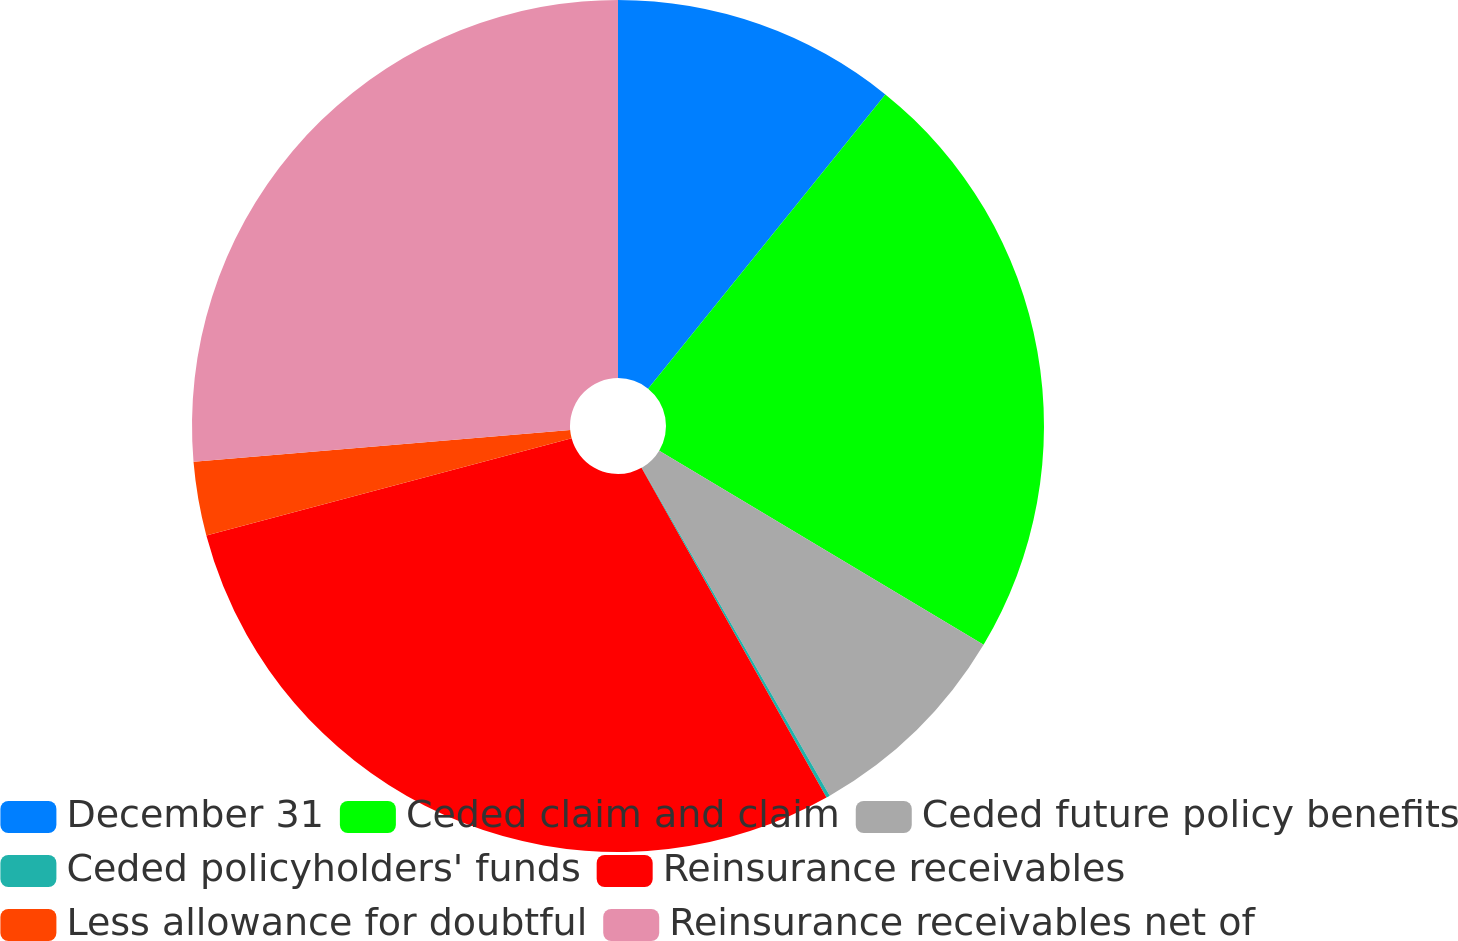Convert chart to OTSL. <chart><loc_0><loc_0><loc_500><loc_500><pie_chart><fcel>December 31<fcel>Ceded claim and claim<fcel>Ceded future policy benefits<fcel>Ceded policyholders' funds<fcel>Reinsurance receivables<fcel>Less allowance for doubtful<fcel>Reinsurance receivables net of<nl><fcel>10.8%<fcel>22.78%<fcel>8.14%<fcel>0.14%<fcel>29.0%<fcel>2.8%<fcel>26.34%<nl></chart> 